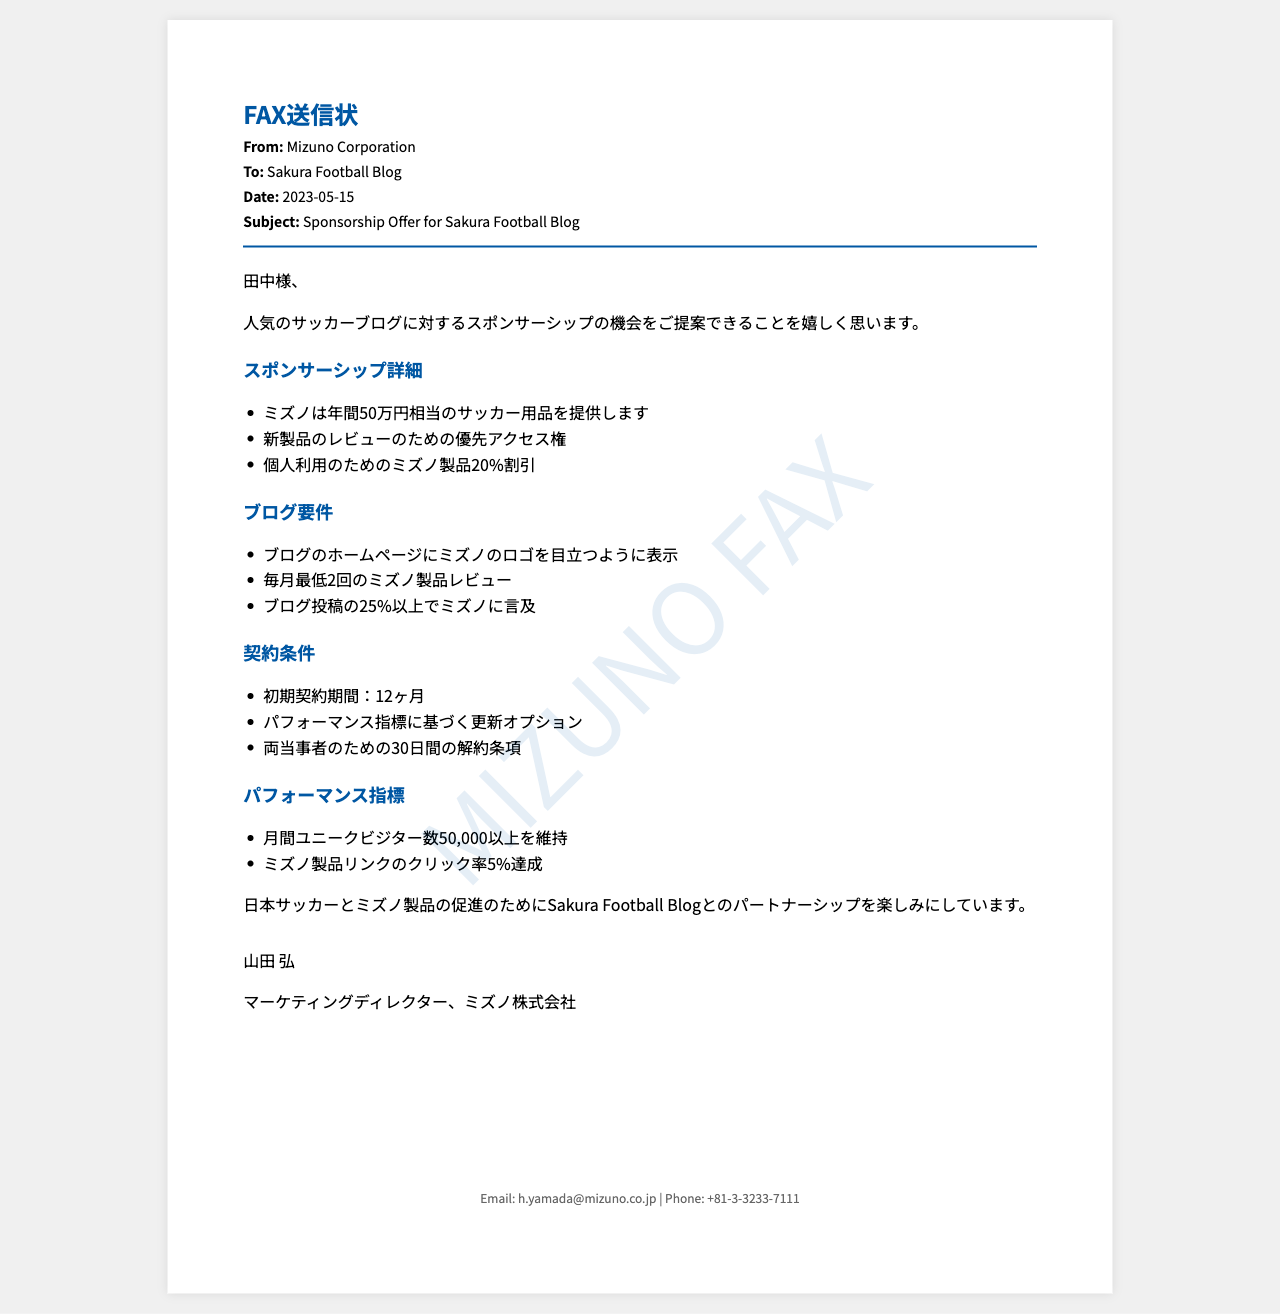What is the company offering the sponsorship? The document states that Mizuno Corporation is offering the sponsorship.
Answer: Mizuno Corporation Who is the intended recipient of the fax? The fax is addressed to Sakura Football Blog.
Answer: Sakura Football Blog What is the date of the fax? The document specifies that the fax was sent on May 15, 2023.
Answer: 2023-05-15 What is the value of the sponsorship offer? The document mentions an annual value of 500,000 yen worth of soccer equipment.
Answer: 50万円 What are the performance criteria for the blog? The document lists that the blog must maintain over 50,000 unique visitors per month.
Answer: 50,000 What percentage of blog posts should mention Mizuno? The document states that at least 25% of blog posts must mention Mizuno.
Answer: 25% How long is the initial contract period? According to the document, the initial contract period is 12 months.
Answer: 12ヶ月 What is the email address provided in the footer? The document provides the email address for correspondence, which is h.yamada@mizuno.co.jp.
Answer: h.yamada@mizuno.co.jp What type of document is this? The document is a fax communication regarding a sponsorship offer.
Answer: FAX送信状 